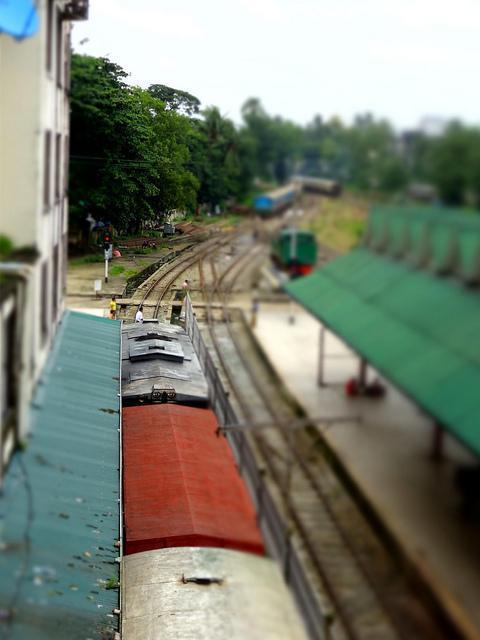What color is the train car in the center of the three cars?
Choose the right answer from the provided options to respond to the question.
Options: Red, blue, gray, white. Red. Who works at one of these places?
From the following four choices, select the correct answer to address the question.
Options: Conductor, airline pilot, rodeo clown, zoo keeper. Conductor. 